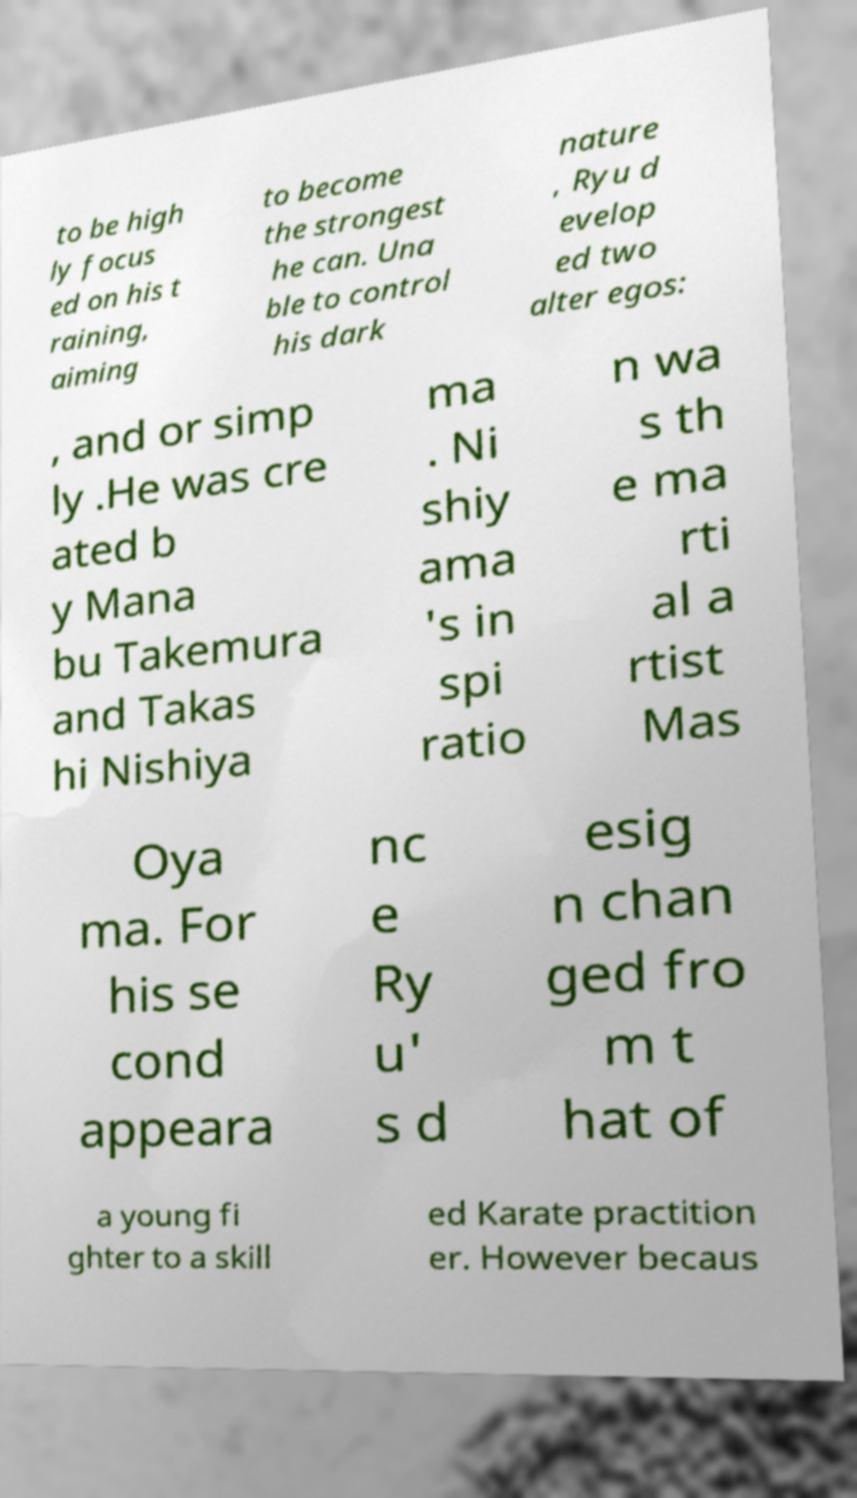Could you extract and type out the text from this image? to be high ly focus ed on his t raining, aiming to become the strongest he can. Una ble to control his dark nature , Ryu d evelop ed two alter egos: , and or simp ly .He was cre ated b y Mana bu Takemura and Takas hi Nishiya ma . Ni shiy ama 's in spi ratio n wa s th e ma rti al a rtist Mas Oya ma. For his se cond appeara nc e Ry u' s d esig n chan ged fro m t hat of a young fi ghter to a skill ed Karate practition er. However becaus 